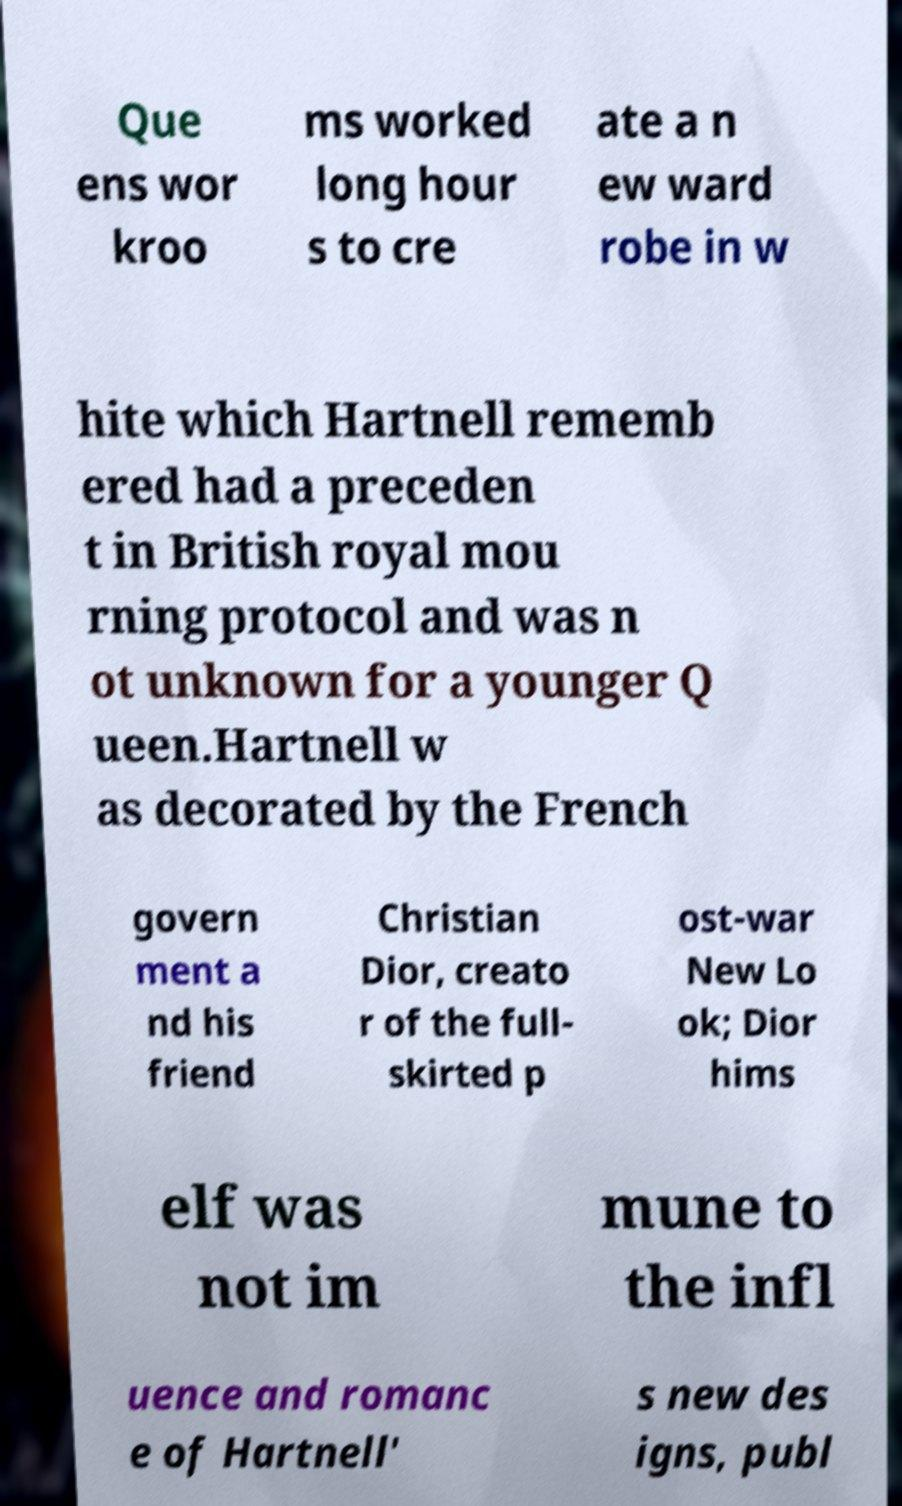For documentation purposes, I need the text within this image transcribed. Could you provide that? Que ens wor kroo ms worked long hour s to cre ate a n ew ward robe in w hite which Hartnell rememb ered had a preceden t in British royal mou rning protocol and was n ot unknown for a younger Q ueen.Hartnell w as decorated by the French govern ment a nd his friend Christian Dior, creato r of the full- skirted p ost-war New Lo ok; Dior hims elf was not im mune to the infl uence and romanc e of Hartnell' s new des igns, publ 